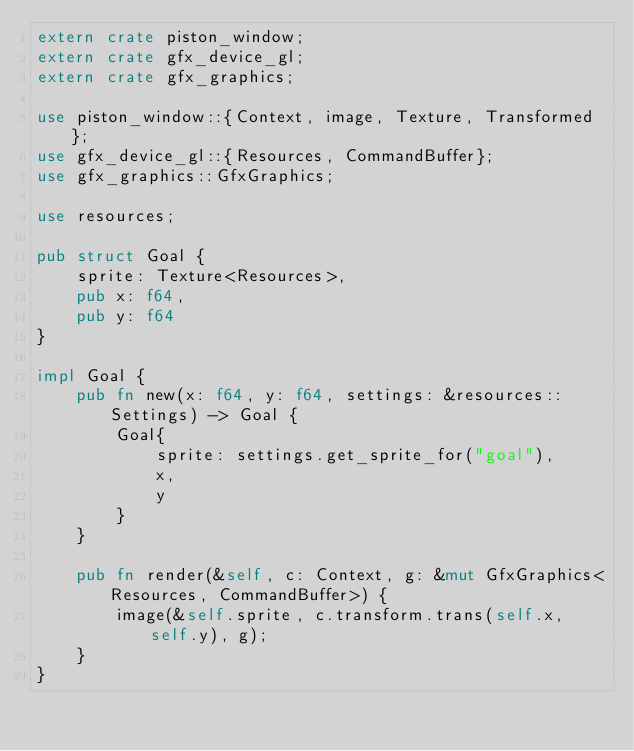<code> <loc_0><loc_0><loc_500><loc_500><_Rust_>extern crate piston_window;
extern crate gfx_device_gl;
extern crate gfx_graphics;

use piston_window::{Context, image, Texture, Transformed};
use gfx_device_gl::{Resources, CommandBuffer};
use gfx_graphics::GfxGraphics;

use resources;

pub struct Goal {
    sprite: Texture<Resources>,
    pub x: f64,
    pub y: f64
}

impl Goal {
    pub fn new(x: f64, y: f64, settings: &resources::Settings) -> Goal {
        Goal{
            sprite: settings.get_sprite_for("goal"),
            x,
            y
        }
    }

    pub fn render(&self, c: Context, g: &mut GfxGraphics<Resources, CommandBuffer>) {
        image(&self.sprite, c.transform.trans(self.x, self.y), g);
    }
}
</code> 